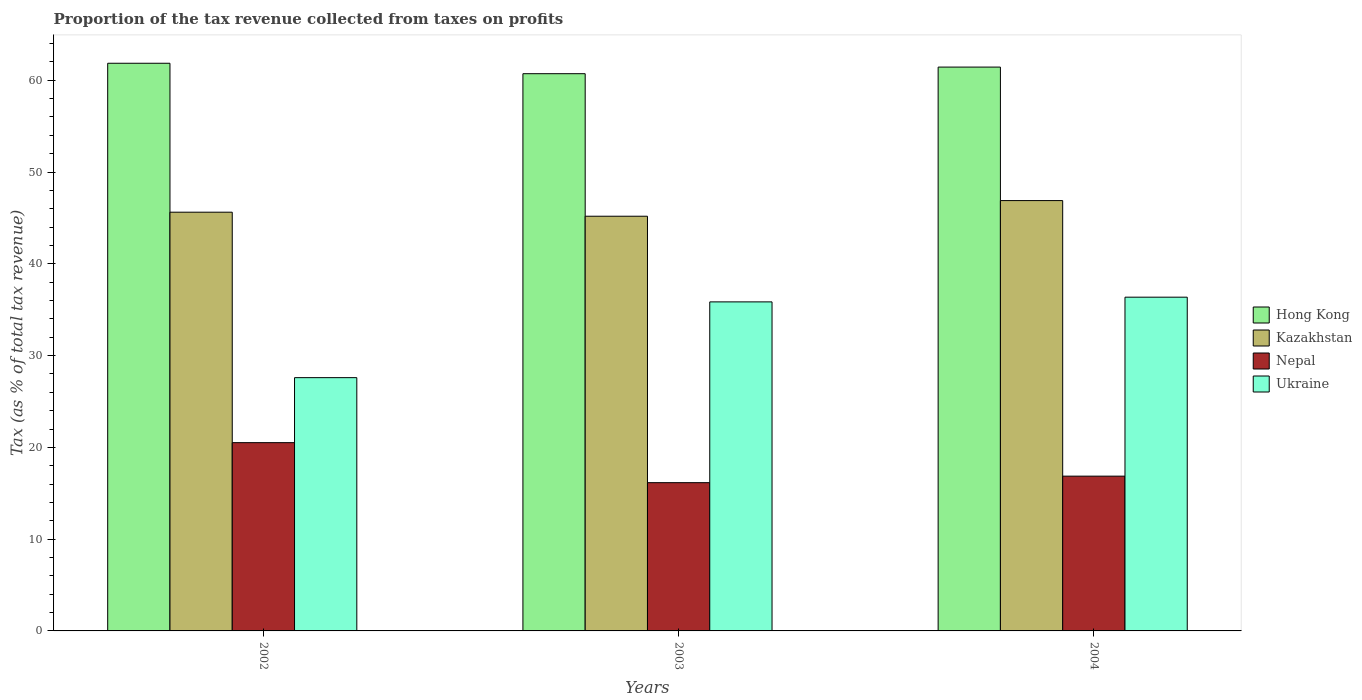How many groups of bars are there?
Make the answer very short. 3. Are the number of bars per tick equal to the number of legend labels?
Your answer should be compact. Yes. Are the number of bars on each tick of the X-axis equal?
Offer a very short reply. Yes. How many bars are there on the 2nd tick from the left?
Your answer should be very brief. 4. How many bars are there on the 3rd tick from the right?
Your response must be concise. 4. What is the proportion of the tax revenue collected in Hong Kong in 2003?
Give a very brief answer. 60.71. Across all years, what is the maximum proportion of the tax revenue collected in Hong Kong?
Keep it short and to the point. 61.85. Across all years, what is the minimum proportion of the tax revenue collected in Nepal?
Provide a succinct answer. 16.15. In which year was the proportion of the tax revenue collected in Hong Kong minimum?
Offer a very short reply. 2003. What is the total proportion of the tax revenue collected in Kazakhstan in the graph?
Offer a terse response. 137.69. What is the difference between the proportion of the tax revenue collected in Nepal in 2003 and that in 2004?
Keep it short and to the point. -0.71. What is the difference between the proportion of the tax revenue collected in Kazakhstan in 2002 and the proportion of the tax revenue collected in Hong Kong in 2004?
Give a very brief answer. -15.81. What is the average proportion of the tax revenue collected in Nepal per year?
Provide a short and direct response. 17.84. In the year 2003, what is the difference between the proportion of the tax revenue collected in Hong Kong and proportion of the tax revenue collected in Kazakhstan?
Your answer should be compact. 15.53. What is the ratio of the proportion of the tax revenue collected in Kazakhstan in 2003 to that in 2004?
Give a very brief answer. 0.96. Is the proportion of the tax revenue collected in Nepal in 2002 less than that in 2003?
Provide a succinct answer. No. What is the difference between the highest and the second highest proportion of the tax revenue collected in Ukraine?
Your response must be concise. 0.51. What is the difference between the highest and the lowest proportion of the tax revenue collected in Kazakhstan?
Give a very brief answer. 1.7. In how many years, is the proportion of the tax revenue collected in Nepal greater than the average proportion of the tax revenue collected in Nepal taken over all years?
Your answer should be compact. 1. Is it the case that in every year, the sum of the proportion of the tax revenue collected in Kazakhstan and proportion of the tax revenue collected in Ukraine is greater than the sum of proportion of the tax revenue collected in Hong Kong and proportion of the tax revenue collected in Nepal?
Your response must be concise. No. What does the 1st bar from the left in 2003 represents?
Offer a terse response. Hong Kong. What does the 2nd bar from the right in 2003 represents?
Provide a succinct answer. Nepal. How many bars are there?
Make the answer very short. 12. What is the difference between two consecutive major ticks on the Y-axis?
Your answer should be very brief. 10. Does the graph contain any zero values?
Keep it short and to the point. No. Does the graph contain grids?
Offer a very short reply. No. Where does the legend appear in the graph?
Keep it short and to the point. Center right. How many legend labels are there?
Keep it short and to the point. 4. How are the legend labels stacked?
Your answer should be compact. Vertical. What is the title of the graph?
Provide a short and direct response. Proportion of the tax revenue collected from taxes on profits. Does "Iran" appear as one of the legend labels in the graph?
Offer a terse response. No. What is the label or title of the X-axis?
Provide a short and direct response. Years. What is the label or title of the Y-axis?
Keep it short and to the point. Tax (as % of total tax revenue). What is the Tax (as % of total tax revenue) of Hong Kong in 2002?
Ensure brevity in your answer.  61.85. What is the Tax (as % of total tax revenue) of Kazakhstan in 2002?
Your answer should be very brief. 45.62. What is the Tax (as % of total tax revenue) in Nepal in 2002?
Your answer should be very brief. 20.51. What is the Tax (as % of total tax revenue) of Ukraine in 2002?
Your response must be concise. 27.59. What is the Tax (as % of total tax revenue) of Hong Kong in 2003?
Offer a terse response. 60.71. What is the Tax (as % of total tax revenue) in Kazakhstan in 2003?
Provide a succinct answer. 45.18. What is the Tax (as % of total tax revenue) in Nepal in 2003?
Ensure brevity in your answer.  16.15. What is the Tax (as % of total tax revenue) of Ukraine in 2003?
Keep it short and to the point. 35.85. What is the Tax (as % of total tax revenue) in Hong Kong in 2004?
Ensure brevity in your answer.  61.43. What is the Tax (as % of total tax revenue) in Kazakhstan in 2004?
Provide a short and direct response. 46.89. What is the Tax (as % of total tax revenue) in Nepal in 2004?
Give a very brief answer. 16.86. What is the Tax (as % of total tax revenue) in Ukraine in 2004?
Keep it short and to the point. 36.36. Across all years, what is the maximum Tax (as % of total tax revenue) of Hong Kong?
Provide a succinct answer. 61.85. Across all years, what is the maximum Tax (as % of total tax revenue) of Kazakhstan?
Offer a very short reply. 46.89. Across all years, what is the maximum Tax (as % of total tax revenue) of Nepal?
Keep it short and to the point. 20.51. Across all years, what is the maximum Tax (as % of total tax revenue) in Ukraine?
Offer a terse response. 36.36. Across all years, what is the minimum Tax (as % of total tax revenue) of Hong Kong?
Your response must be concise. 60.71. Across all years, what is the minimum Tax (as % of total tax revenue) of Kazakhstan?
Offer a very short reply. 45.18. Across all years, what is the minimum Tax (as % of total tax revenue) of Nepal?
Make the answer very short. 16.15. Across all years, what is the minimum Tax (as % of total tax revenue) of Ukraine?
Your response must be concise. 27.59. What is the total Tax (as % of total tax revenue) of Hong Kong in the graph?
Make the answer very short. 183.99. What is the total Tax (as % of total tax revenue) of Kazakhstan in the graph?
Your response must be concise. 137.69. What is the total Tax (as % of total tax revenue) of Nepal in the graph?
Your response must be concise. 53.53. What is the total Tax (as % of total tax revenue) in Ukraine in the graph?
Your response must be concise. 99.81. What is the difference between the Tax (as % of total tax revenue) in Hong Kong in 2002 and that in 2003?
Provide a succinct answer. 1.14. What is the difference between the Tax (as % of total tax revenue) in Kazakhstan in 2002 and that in 2003?
Your answer should be compact. 0.44. What is the difference between the Tax (as % of total tax revenue) of Nepal in 2002 and that in 2003?
Keep it short and to the point. 4.36. What is the difference between the Tax (as % of total tax revenue) in Ukraine in 2002 and that in 2003?
Your answer should be compact. -8.26. What is the difference between the Tax (as % of total tax revenue) of Hong Kong in 2002 and that in 2004?
Provide a short and direct response. 0.42. What is the difference between the Tax (as % of total tax revenue) of Kazakhstan in 2002 and that in 2004?
Give a very brief answer. -1.26. What is the difference between the Tax (as % of total tax revenue) in Nepal in 2002 and that in 2004?
Your response must be concise. 3.65. What is the difference between the Tax (as % of total tax revenue) in Ukraine in 2002 and that in 2004?
Your response must be concise. -8.77. What is the difference between the Tax (as % of total tax revenue) in Hong Kong in 2003 and that in 2004?
Keep it short and to the point. -0.72. What is the difference between the Tax (as % of total tax revenue) in Kazakhstan in 2003 and that in 2004?
Provide a short and direct response. -1.7. What is the difference between the Tax (as % of total tax revenue) in Nepal in 2003 and that in 2004?
Provide a short and direct response. -0.71. What is the difference between the Tax (as % of total tax revenue) in Ukraine in 2003 and that in 2004?
Your response must be concise. -0.51. What is the difference between the Tax (as % of total tax revenue) of Hong Kong in 2002 and the Tax (as % of total tax revenue) of Kazakhstan in 2003?
Offer a very short reply. 16.67. What is the difference between the Tax (as % of total tax revenue) in Hong Kong in 2002 and the Tax (as % of total tax revenue) in Nepal in 2003?
Make the answer very short. 45.7. What is the difference between the Tax (as % of total tax revenue) in Hong Kong in 2002 and the Tax (as % of total tax revenue) in Ukraine in 2003?
Make the answer very short. 26. What is the difference between the Tax (as % of total tax revenue) in Kazakhstan in 2002 and the Tax (as % of total tax revenue) in Nepal in 2003?
Make the answer very short. 29.47. What is the difference between the Tax (as % of total tax revenue) in Kazakhstan in 2002 and the Tax (as % of total tax revenue) in Ukraine in 2003?
Provide a short and direct response. 9.77. What is the difference between the Tax (as % of total tax revenue) in Nepal in 2002 and the Tax (as % of total tax revenue) in Ukraine in 2003?
Offer a very short reply. -15.34. What is the difference between the Tax (as % of total tax revenue) of Hong Kong in 2002 and the Tax (as % of total tax revenue) of Kazakhstan in 2004?
Give a very brief answer. 14.96. What is the difference between the Tax (as % of total tax revenue) of Hong Kong in 2002 and the Tax (as % of total tax revenue) of Nepal in 2004?
Make the answer very short. 44.99. What is the difference between the Tax (as % of total tax revenue) of Hong Kong in 2002 and the Tax (as % of total tax revenue) of Ukraine in 2004?
Provide a short and direct response. 25.49. What is the difference between the Tax (as % of total tax revenue) in Kazakhstan in 2002 and the Tax (as % of total tax revenue) in Nepal in 2004?
Your answer should be very brief. 28.76. What is the difference between the Tax (as % of total tax revenue) of Kazakhstan in 2002 and the Tax (as % of total tax revenue) of Ukraine in 2004?
Offer a very short reply. 9.26. What is the difference between the Tax (as % of total tax revenue) in Nepal in 2002 and the Tax (as % of total tax revenue) in Ukraine in 2004?
Your response must be concise. -15.85. What is the difference between the Tax (as % of total tax revenue) in Hong Kong in 2003 and the Tax (as % of total tax revenue) in Kazakhstan in 2004?
Keep it short and to the point. 13.82. What is the difference between the Tax (as % of total tax revenue) of Hong Kong in 2003 and the Tax (as % of total tax revenue) of Nepal in 2004?
Ensure brevity in your answer.  43.85. What is the difference between the Tax (as % of total tax revenue) of Hong Kong in 2003 and the Tax (as % of total tax revenue) of Ukraine in 2004?
Your response must be concise. 24.35. What is the difference between the Tax (as % of total tax revenue) in Kazakhstan in 2003 and the Tax (as % of total tax revenue) in Nepal in 2004?
Keep it short and to the point. 28.32. What is the difference between the Tax (as % of total tax revenue) of Kazakhstan in 2003 and the Tax (as % of total tax revenue) of Ukraine in 2004?
Provide a short and direct response. 8.82. What is the difference between the Tax (as % of total tax revenue) in Nepal in 2003 and the Tax (as % of total tax revenue) in Ukraine in 2004?
Provide a short and direct response. -20.21. What is the average Tax (as % of total tax revenue) of Hong Kong per year?
Ensure brevity in your answer.  61.33. What is the average Tax (as % of total tax revenue) of Kazakhstan per year?
Your response must be concise. 45.9. What is the average Tax (as % of total tax revenue) in Nepal per year?
Give a very brief answer. 17.84. What is the average Tax (as % of total tax revenue) of Ukraine per year?
Provide a short and direct response. 33.27. In the year 2002, what is the difference between the Tax (as % of total tax revenue) of Hong Kong and Tax (as % of total tax revenue) of Kazakhstan?
Make the answer very short. 16.23. In the year 2002, what is the difference between the Tax (as % of total tax revenue) in Hong Kong and Tax (as % of total tax revenue) in Nepal?
Offer a very short reply. 41.34. In the year 2002, what is the difference between the Tax (as % of total tax revenue) in Hong Kong and Tax (as % of total tax revenue) in Ukraine?
Provide a short and direct response. 34.25. In the year 2002, what is the difference between the Tax (as % of total tax revenue) in Kazakhstan and Tax (as % of total tax revenue) in Nepal?
Offer a terse response. 25.11. In the year 2002, what is the difference between the Tax (as % of total tax revenue) in Kazakhstan and Tax (as % of total tax revenue) in Ukraine?
Your answer should be very brief. 18.03. In the year 2002, what is the difference between the Tax (as % of total tax revenue) in Nepal and Tax (as % of total tax revenue) in Ukraine?
Offer a terse response. -7.08. In the year 2003, what is the difference between the Tax (as % of total tax revenue) of Hong Kong and Tax (as % of total tax revenue) of Kazakhstan?
Provide a short and direct response. 15.53. In the year 2003, what is the difference between the Tax (as % of total tax revenue) in Hong Kong and Tax (as % of total tax revenue) in Nepal?
Your response must be concise. 44.56. In the year 2003, what is the difference between the Tax (as % of total tax revenue) of Hong Kong and Tax (as % of total tax revenue) of Ukraine?
Offer a very short reply. 24.86. In the year 2003, what is the difference between the Tax (as % of total tax revenue) in Kazakhstan and Tax (as % of total tax revenue) in Nepal?
Your answer should be very brief. 29.03. In the year 2003, what is the difference between the Tax (as % of total tax revenue) of Kazakhstan and Tax (as % of total tax revenue) of Ukraine?
Your answer should be very brief. 9.33. In the year 2003, what is the difference between the Tax (as % of total tax revenue) in Nepal and Tax (as % of total tax revenue) in Ukraine?
Give a very brief answer. -19.7. In the year 2004, what is the difference between the Tax (as % of total tax revenue) of Hong Kong and Tax (as % of total tax revenue) of Kazakhstan?
Keep it short and to the point. 14.54. In the year 2004, what is the difference between the Tax (as % of total tax revenue) in Hong Kong and Tax (as % of total tax revenue) in Nepal?
Make the answer very short. 44.57. In the year 2004, what is the difference between the Tax (as % of total tax revenue) of Hong Kong and Tax (as % of total tax revenue) of Ukraine?
Ensure brevity in your answer.  25.07. In the year 2004, what is the difference between the Tax (as % of total tax revenue) in Kazakhstan and Tax (as % of total tax revenue) in Nepal?
Provide a succinct answer. 30.02. In the year 2004, what is the difference between the Tax (as % of total tax revenue) in Kazakhstan and Tax (as % of total tax revenue) in Ukraine?
Offer a very short reply. 10.52. In the year 2004, what is the difference between the Tax (as % of total tax revenue) in Nepal and Tax (as % of total tax revenue) in Ukraine?
Your answer should be very brief. -19.5. What is the ratio of the Tax (as % of total tax revenue) in Hong Kong in 2002 to that in 2003?
Make the answer very short. 1.02. What is the ratio of the Tax (as % of total tax revenue) in Kazakhstan in 2002 to that in 2003?
Provide a succinct answer. 1.01. What is the ratio of the Tax (as % of total tax revenue) of Nepal in 2002 to that in 2003?
Ensure brevity in your answer.  1.27. What is the ratio of the Tax (as % of total tax revenue) of Ukraine in 2002 to that in 2003?
Offer a very short reply. 0.77. What is the ratio of the Tax (as % of total tax revenue) in Hong Kong in 2002 to that in 2004?
Offer a terse response. 1.01. What is the ratio of the Tax (as % of total tax revenue) of Nepal in 2002 to that in 2004?
Your answer should be compact. 1.22. What is the ratio of the Tax (as % of total tax revenue) of Ukraine in 2002 to that in 2004?
Your answer should be compact. 0.76. What is the ratio of the Tax (as % of total tax revenue) in Hong Kong in 2003 to that in 2004?
Offer a terse response. 0.99. What is the ratio of the Tax (as % of total tax revenue) of Kazakhstan in 2003 to that in 2004?
Provide a short and direct response. 0.96. What is the ratio of the Tax (as % of total tax revenue) of Nepal in 2003 to that in 2004?
Offer a very short reply. 0.96. What is the ratio of the Tax (as % of total tax revenue) of Ukraine in 2003 to that in 2004?
Provide a short and direct response. 0.99. What is the difference between the highest and the second highest Tax (as % of total tax revenue) of Hong Kong?
Your answer should be compact. 0.42. What is the difference between the highest and the second highest Tax (as % of total tax revenue) of Kazakhstan?
Your response must be concise. 1.26. What is the difference between the highest and the second highest Tax (as % of total tax revenue) of Nepal?
Ensure brevity in your answer.  3.65. What is the difference between the highest and the second highest Tax (as % of total tax revenue) of Ukraine?
Make the answer very short. 0.51. What is the difference between the highest and the lowest Tax (as % of total tax revenue) of Hong Kong?
Offer a very short reply. 1.14. What is the difference between the highest and the lowest Tax (as % of total tax revenue) in Kazakhstan?
Ensure brevity in your answer.  1.7. What is the difference between the highest and the lowest Tax (as % of total tax revenue) in Nepal?
Offer a terse response. 4.36. What is the difference between the highest and the lowest Tax (as % of total tax revenue) of Ukraine?
Give a very brief answer. 8.77. 